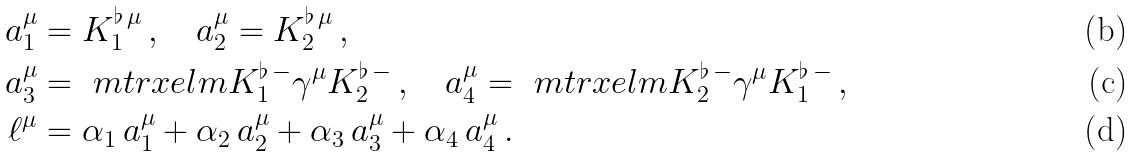<formula> <loc_0><loc_0><loc_500><loc_500>a _ { 1 } ^ { \mu } & = K _ { 1 } ^ { \flat \, \mu } \, , \quad a _ { 2 } ^ { \mu } = K _ { 2 } ^ { \flat \, \mu } \, , \\ a _ { 3 } ^ { \mu } & = \ m t r x e l m { K _ { 1 } ^ { \flat \, - } } { \gamma ^ { \mu } } { K _ { 2 } ^ { \flat \, - } } \, , \quad a _ { 4 } ^ { \mu } = \ m t r x e l m { K _ { 2 } ^ { \flat \, - } } { \gamma ^ { \mu } } { K _ { 1 } ^ { \flat \, - } } \, , \\ \ell ^ { \mu } & = \alpha _ { 1 } \, a _ { 1 } ^ { \mu } + \alpha _ { 2 } \, a _ { 2 } ^ { \mu } + \alpha _ { 3 } \, a _ { 3 } ^ { \mu } + \alpha _ { 4 } \, a _ { 4 } ^ { \mu } \, .</formula> 